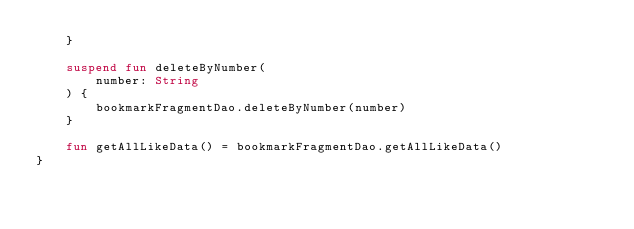<code> <loc_0><loc_0><loc_500><loc_500><_Kotlin_>    }

    suspend fun deleteByNumber(
        number: String
    ) {
        bookmarkFragmentDao.deleteByNumber(number)
    }

    fun getAllLikeData() = bookmarkFragmentDao.getAllLikeData()
}</code> 